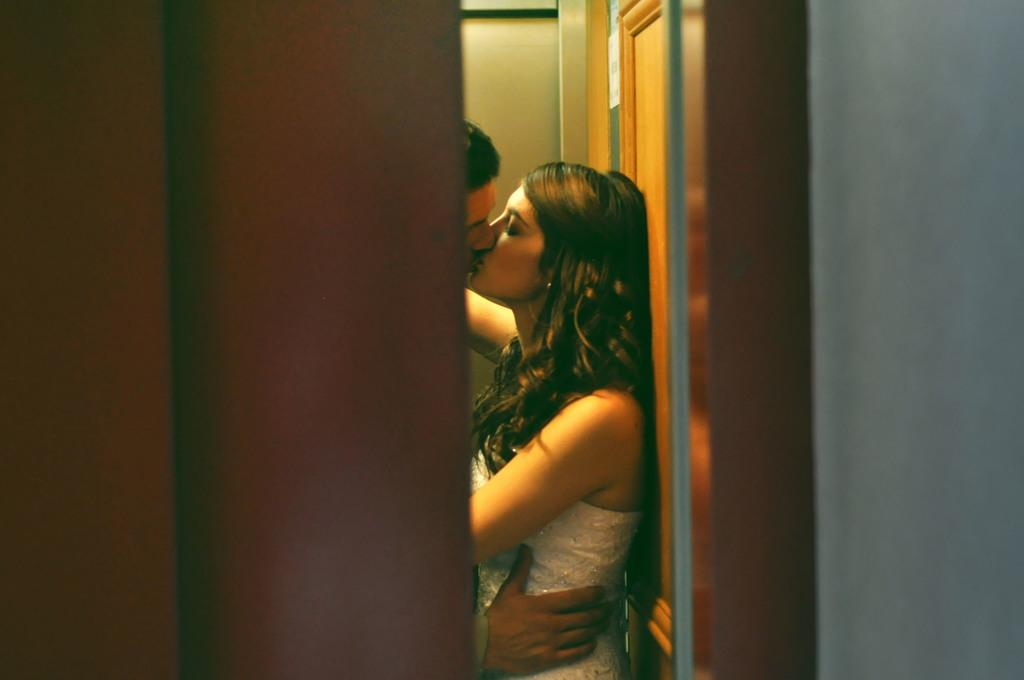How many people are present in the image? There are two people in the image, a man and a woman. What are the man and woman doing in the image? The man and woman are kissing each other. Can you describe any architectural features in the image? Yes, there is a wooden door in the image. What is the size of the amusement park in the image? There is no amusement park present in the image; it features a man and a woman kissing each other and a wooden door. 